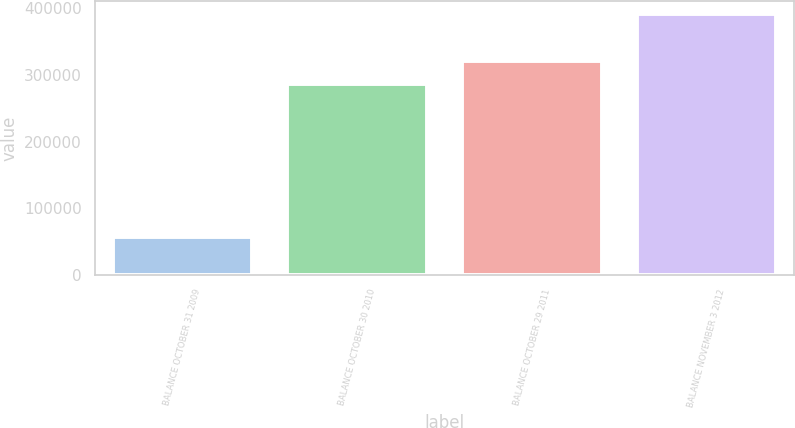Convert chart to OTSL. <chart><loc_0><loc_0><loc_500><loc_500><bar_chart><fcel>BALANCE OCTOBER 31 2009<fcel>BALANCE OCTOBER 30 2010<fcel>BALANCE OCTOBER 29 2011<fcel>BALANCE NOVEMBER 3 2012<nl><fcel>56306<fcel>286969<fcel>320404<fcel>390651<nl></chart> 